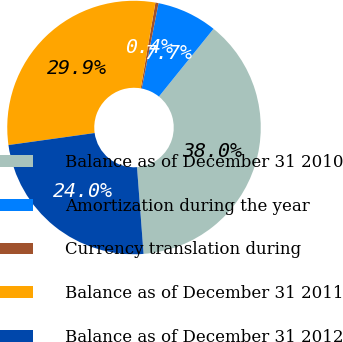Convert chart to OTSL. <chart><loc_0><loc_0><loc_500><loc_500><pie_chart><fcel>Balance as of December 31 2010<fcel>Amortization during the year<fcel>Currency translation during<fcel>Balance as of December 31 2011<fcel>Balance as of December 31 2012<nl><fcel>38.0%<fcel>7.69%<fcel>0.4%<fcel>29.91%<fcel>23.99%<nl></chart> 